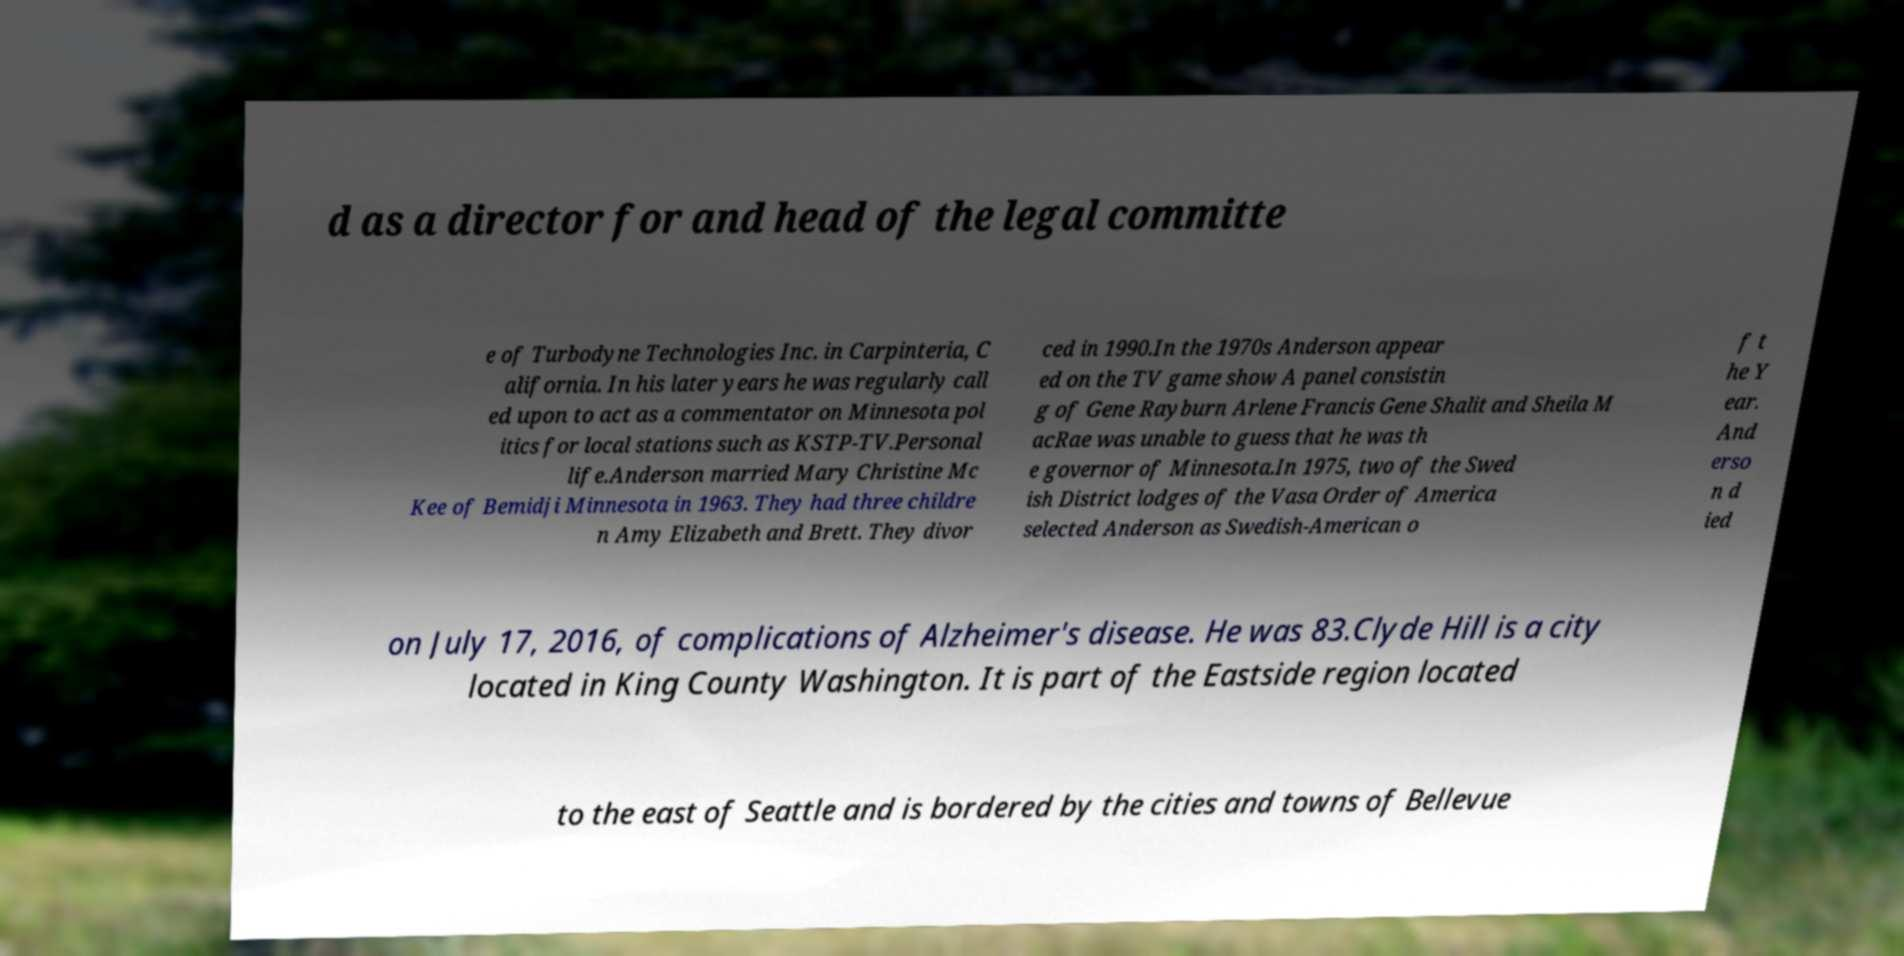Please read and relay the text visible in this image. What does it say? d as a director for and head of the legal committe e of Turbodyne Technologies Inc. in Carpinteria, C alifornia. In his later years he was regularly call ed upon to act as a commentator on Minnesota pol itics for local stations such as KSTP-TV.Personal life.Anderson married Mary Christine Mc Kee of Bemidji Minnesota in 1963. They had three childre n Amy Elizabeth and Brett. They divor ced in 1990.In the 1970s Anderson appear ed on the TV game show A panel consistin g of Gene Rayburn Arlene Francis Gene Shalit and Sheila M acRae was unable to guess that he was th e governor of Minnesota.In 1975, two of the Swed ish District lodges of the Vasa Order of America selected Anderson as Swedish-American o f t he Y ear. And erso n d ied on July 17, 2016, of complications of Alzheimer's disease. He was 83.Clyde Hill is a city located in King County Washington. It is part of the Eastside region located to the east of Seattle and is bordered by the cities and towns of Bellevue 